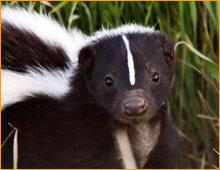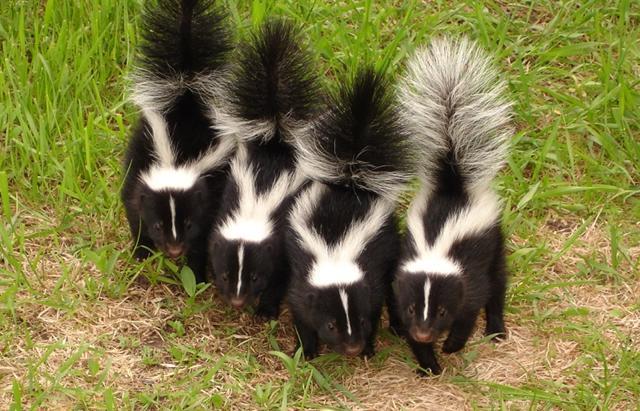The first image is the image on the left, the second image is the image on the right. For the images shown, is this caption "The left image shows a reddish-brown canine facing the tail end of a skunk, and the right image features one solitary skunk that is not in profile." true? Answer yes or no. No. The first image is the image on the left, the second image is the image on the right. Evaluate the accuracy of this statement regarding the images: "In the left image there is a skunk and one other animal.". Is it true? Answer yes or no. No. 